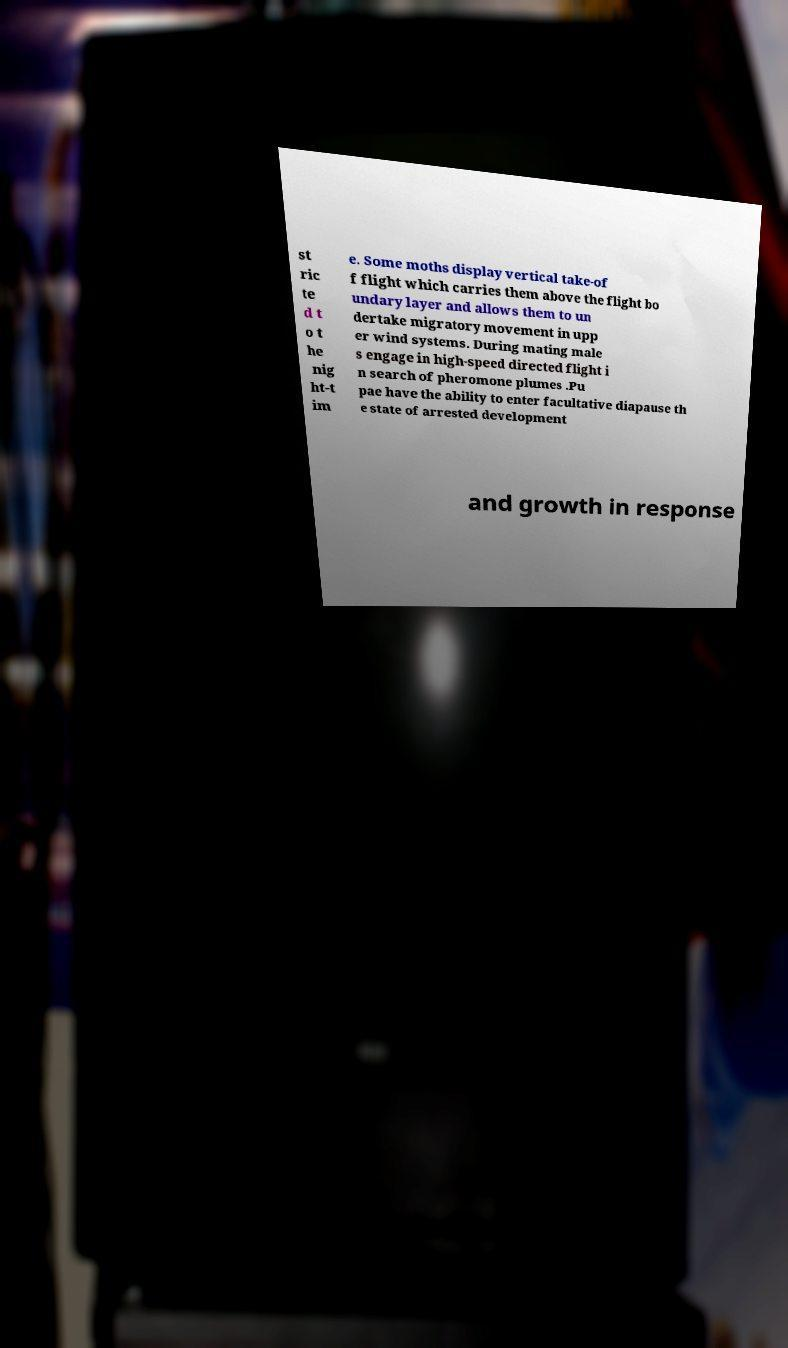For documentation purposes, I need the text within this image transcribed. Could you provide that? st ric te d t o t he nig ht-t im e. Some moths display vertical take-of f flight which carries them above the flight bo undary layer and allows them to un dertake migratory movement in upp er wind systems. During mating male s engage in high-speed directed flight i n search of pheromone plumes .Pu pae have the ability to enter facultative diapause th e state of arrested development and growth in response 